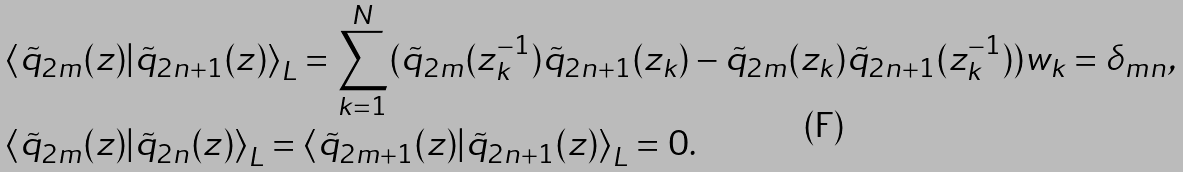Convert formula to latex. <formula><loc_0><loc_0><loc_500><loc_500>& \left < \tilde { q } _ { 2 m } ( z ) | \tilde { q } _ { 2 n + 1 } ( z ) \right > _ { L } = \sum _ { k = 1 } ^ { N } ( \tilde { q } _ { 2 m } ( z _ { k } ^ { - 1 } ) \tilde { q } _ { 2 n + 1 } ( z _ { k } ) - \tilde { q } _ { 2 m } ( z _ { k } ) \tilde { q } _ { 2 n + 1 } ( z _ { k } ^ { - 1 } ) ) w _ { k } = \delta _ { m n } , \\ & \left < \tilde { q } _ { 2 m } ( z ) | \tilde { q } _ { 2 n } ( z ) \right > _ { L } = \left < \tilde { q } _ { 2 m + 1 } ( z ) | \tilde { q } _ { 2 n + 1 } ( z ) \right > _ { L } = 0 .</formula> 